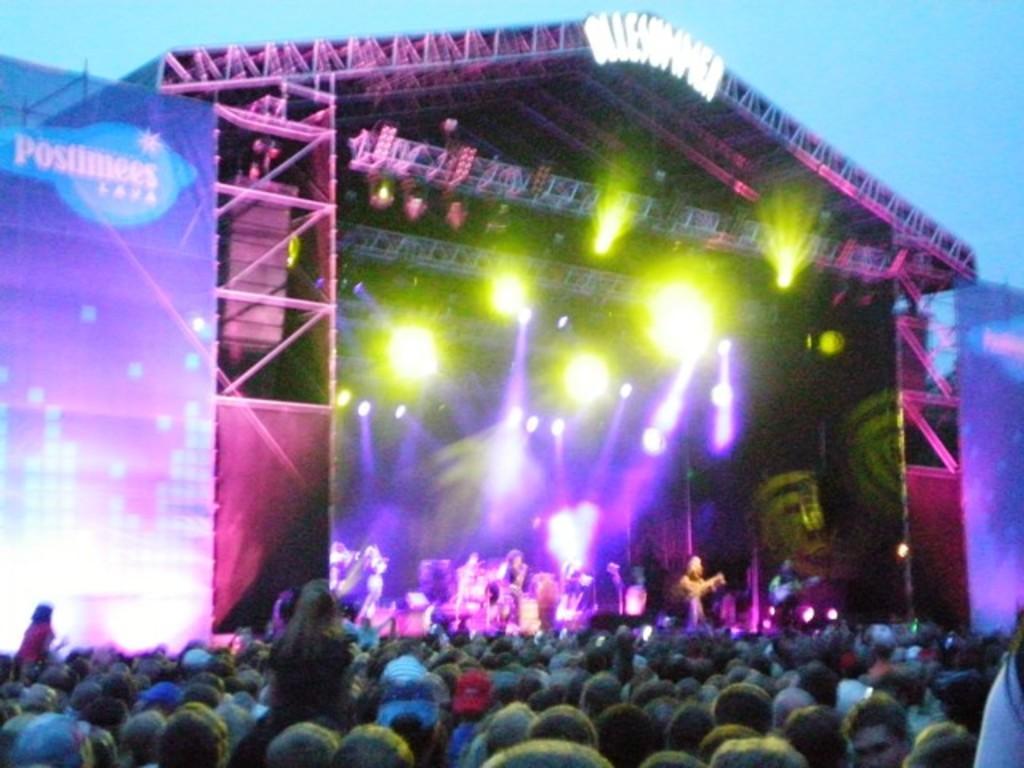How would you summarize this image in a sentence or two? There are persons in front of a stage on which, there are persons standing. Above this stage, there are lights arranged and there is a roof. On both sides of this stage, there is a screen. In the background, there is sky. 